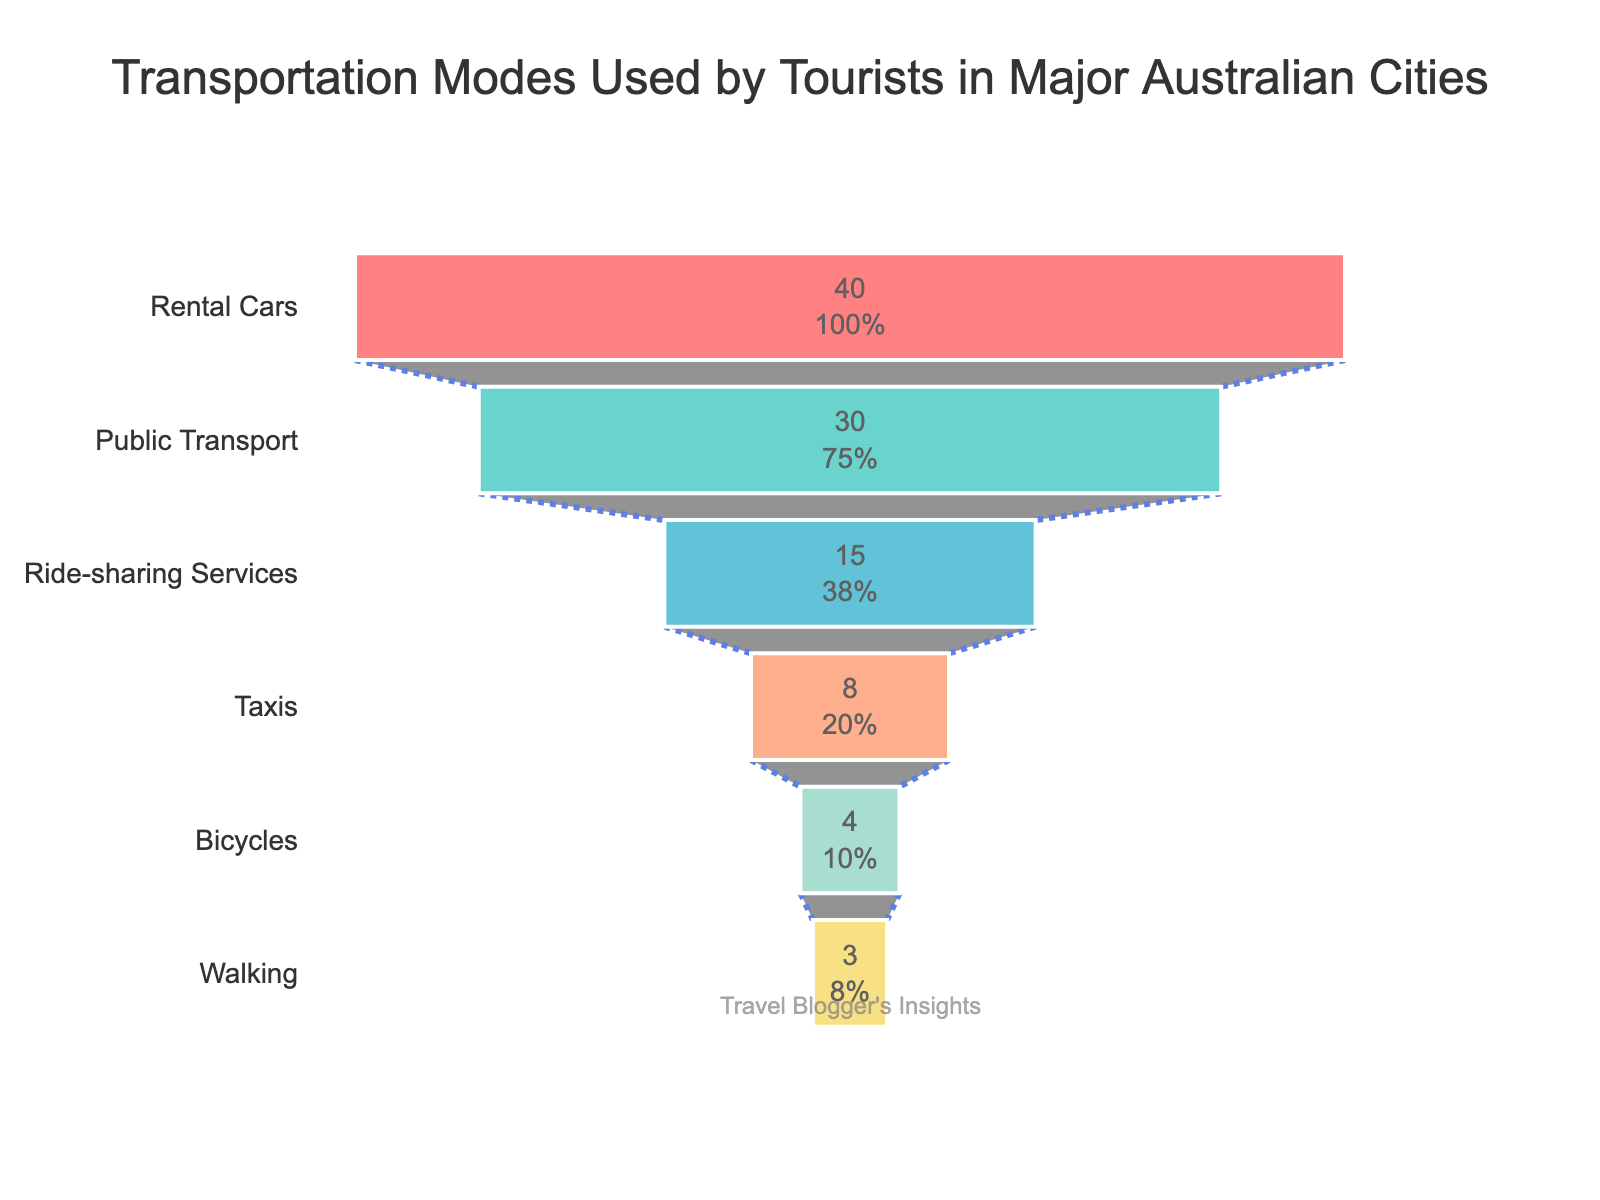What transportation mode is the most used by tourists in major Australian cities? The figure shows the distribution of transportation modes. Rental cars have the largest portion at the top of the funnel chart, indicating they are the most used.
Answer: Rental cars What percentage of tourists use public transport? The figure labels the percentages inside each section of the funnel. The section for public transport shows 30%.
Answer: 30% Which transportation mode has the least usage by tourists? The figure displays the transportation modes from highest to lowest usage. Walking is at the bottom with the smallest portion.
Answer: Walking What is the combined percentage of tourists using either public transport or taxis? The percentages for public transport and taxis are 30% and 8%, respectively. Summing them gives 30 + 8 = 38%.
Answer: 38% How does the usage of ride-sharing services compare to taxis? Ride-sharing services have a 15% usage rate, while taxis have an 8% usage rate. Thus, ride-sharing services are more used.
Answer: Ride-sharing services are more used What is the difference in usage percentage between rental cars and bicycles? Rental cars have a usage percentage of 40%, and bicycles have 4%. The difference is 40% - 4% = 36%.
Answer: 36% Which transportation mode accounts for 15% of the tourist usage? The figure indicates that ride-sharing services account for 15%.
Answer: Ride-sharing services How many transportation modes have a usage percentage below 10%? The modes with percentages below 10% are Taxis (8%), Bicycles (4%), and Walking (3%). There are three transportation modes.
Answer: 3 By how much does public transport usage exceed bicycle usage? Public transport is used by 30% of tourists, while bicycles are used by 4%. The difference is 30% - 4% = 26%.
Answer: 26% What modes of transportation make up over 50% of the total usage collectively? Rental cars (40%) and public transport (30%) collectively sum to 70%, surpassing 50%.
Answer: Rental cars and public transport 